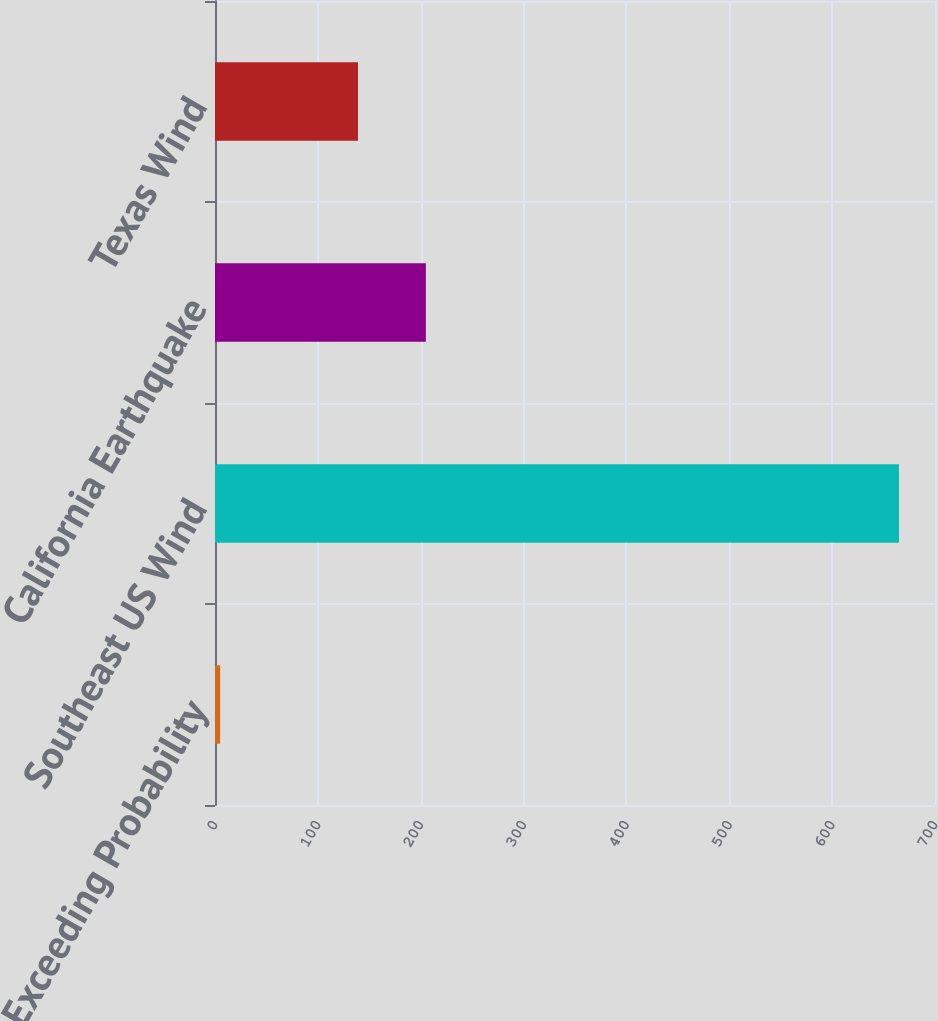Convert chart to OTSL. <chart><loc_0><loc_0><loc_500><loc_500><bar_chart><fcel>Exceeding Probability<fcel>Southeast US Wind<fcel>California Earthquake<fcel>Texas Wind<nl><fcel>5<fcel>665<fcel>205<fcel>139<nl></chart> 